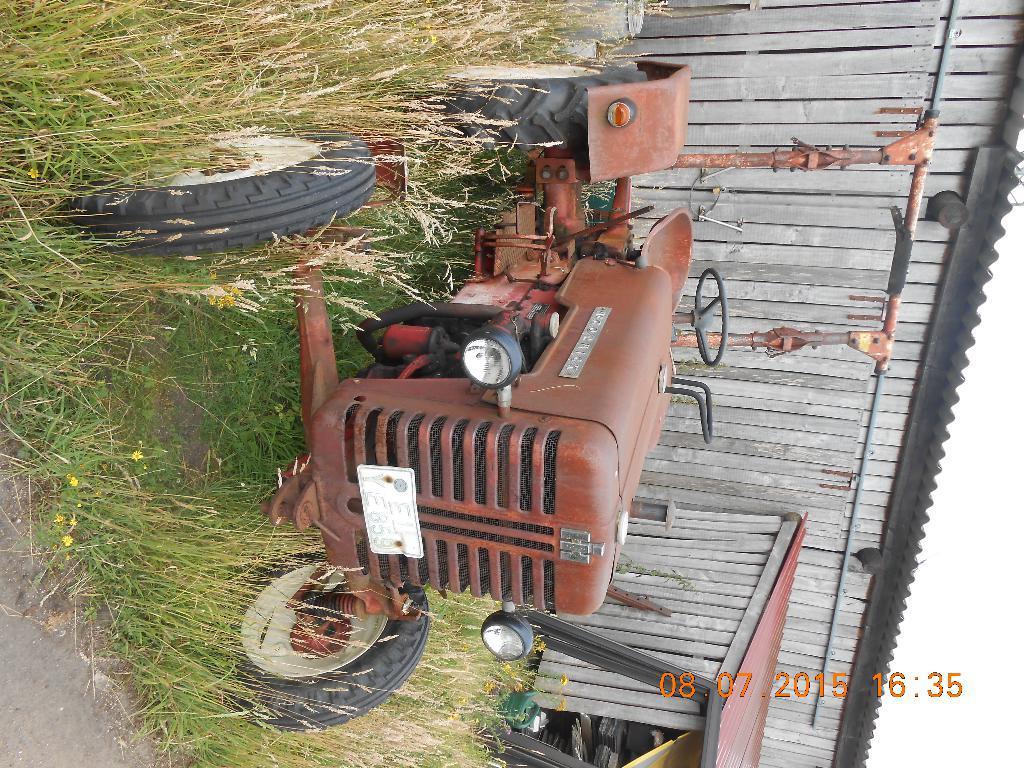Could you give a brief overview of what you see in this image? This is a tilted picture. In this picture we can see a tractor, shed, plans. In the bottom right corner of the picture we can see date and time. 